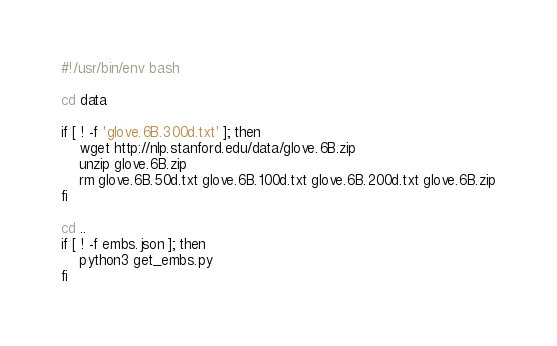<code> <loc_0><loc_0><loc_500><loc_500><_Bash_>#!/usr/bin/env bash

cd data

if [ ! -f 'glove.6B.300d.txt' ]; then
    wget http://nlp.stanford.edu/data/glove.6B.zip
    unzip glove.6B.zip
    rm glove.6B.50d.txt glove.6B.100d.txt glove.6B.200d.txt glove.6B.zip
fi

cd ..
if [ ! -f embs.json ]; then
    python3 get_embs.py
fi
</code> 